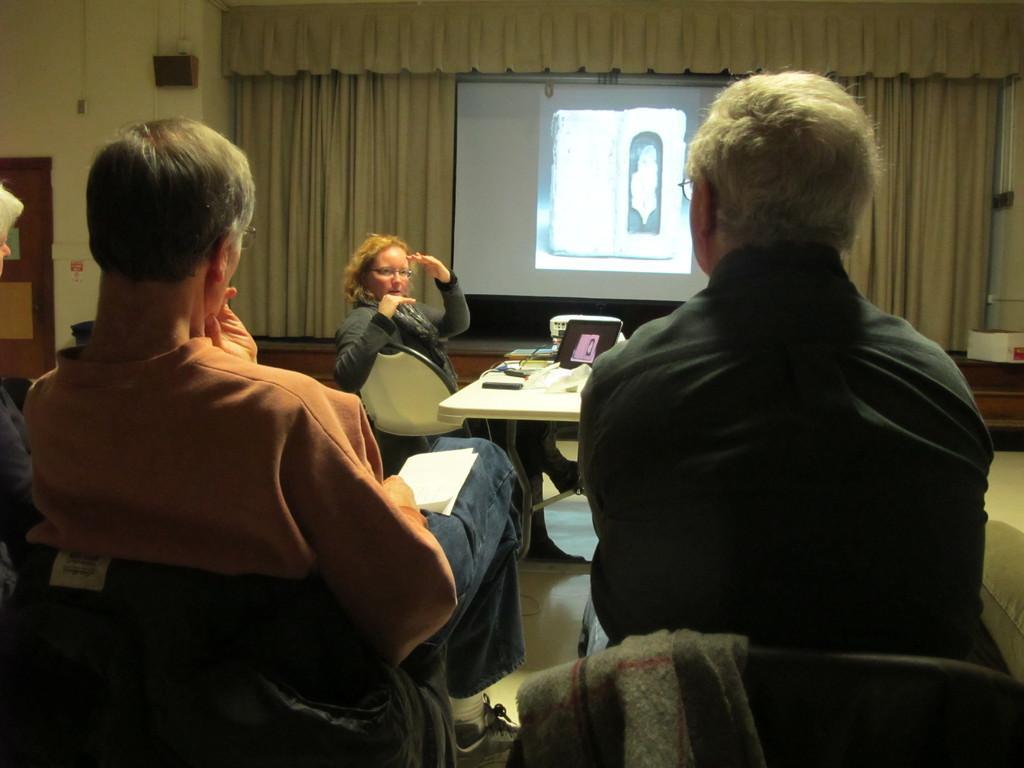Describe this image in one or two sentences. A screen is on curtain. These three persons are sitting on chairs. Beside this woman there is a table, on this table there is a laptop and things. This man is holding a paper. On this chairs there is a jacket. 